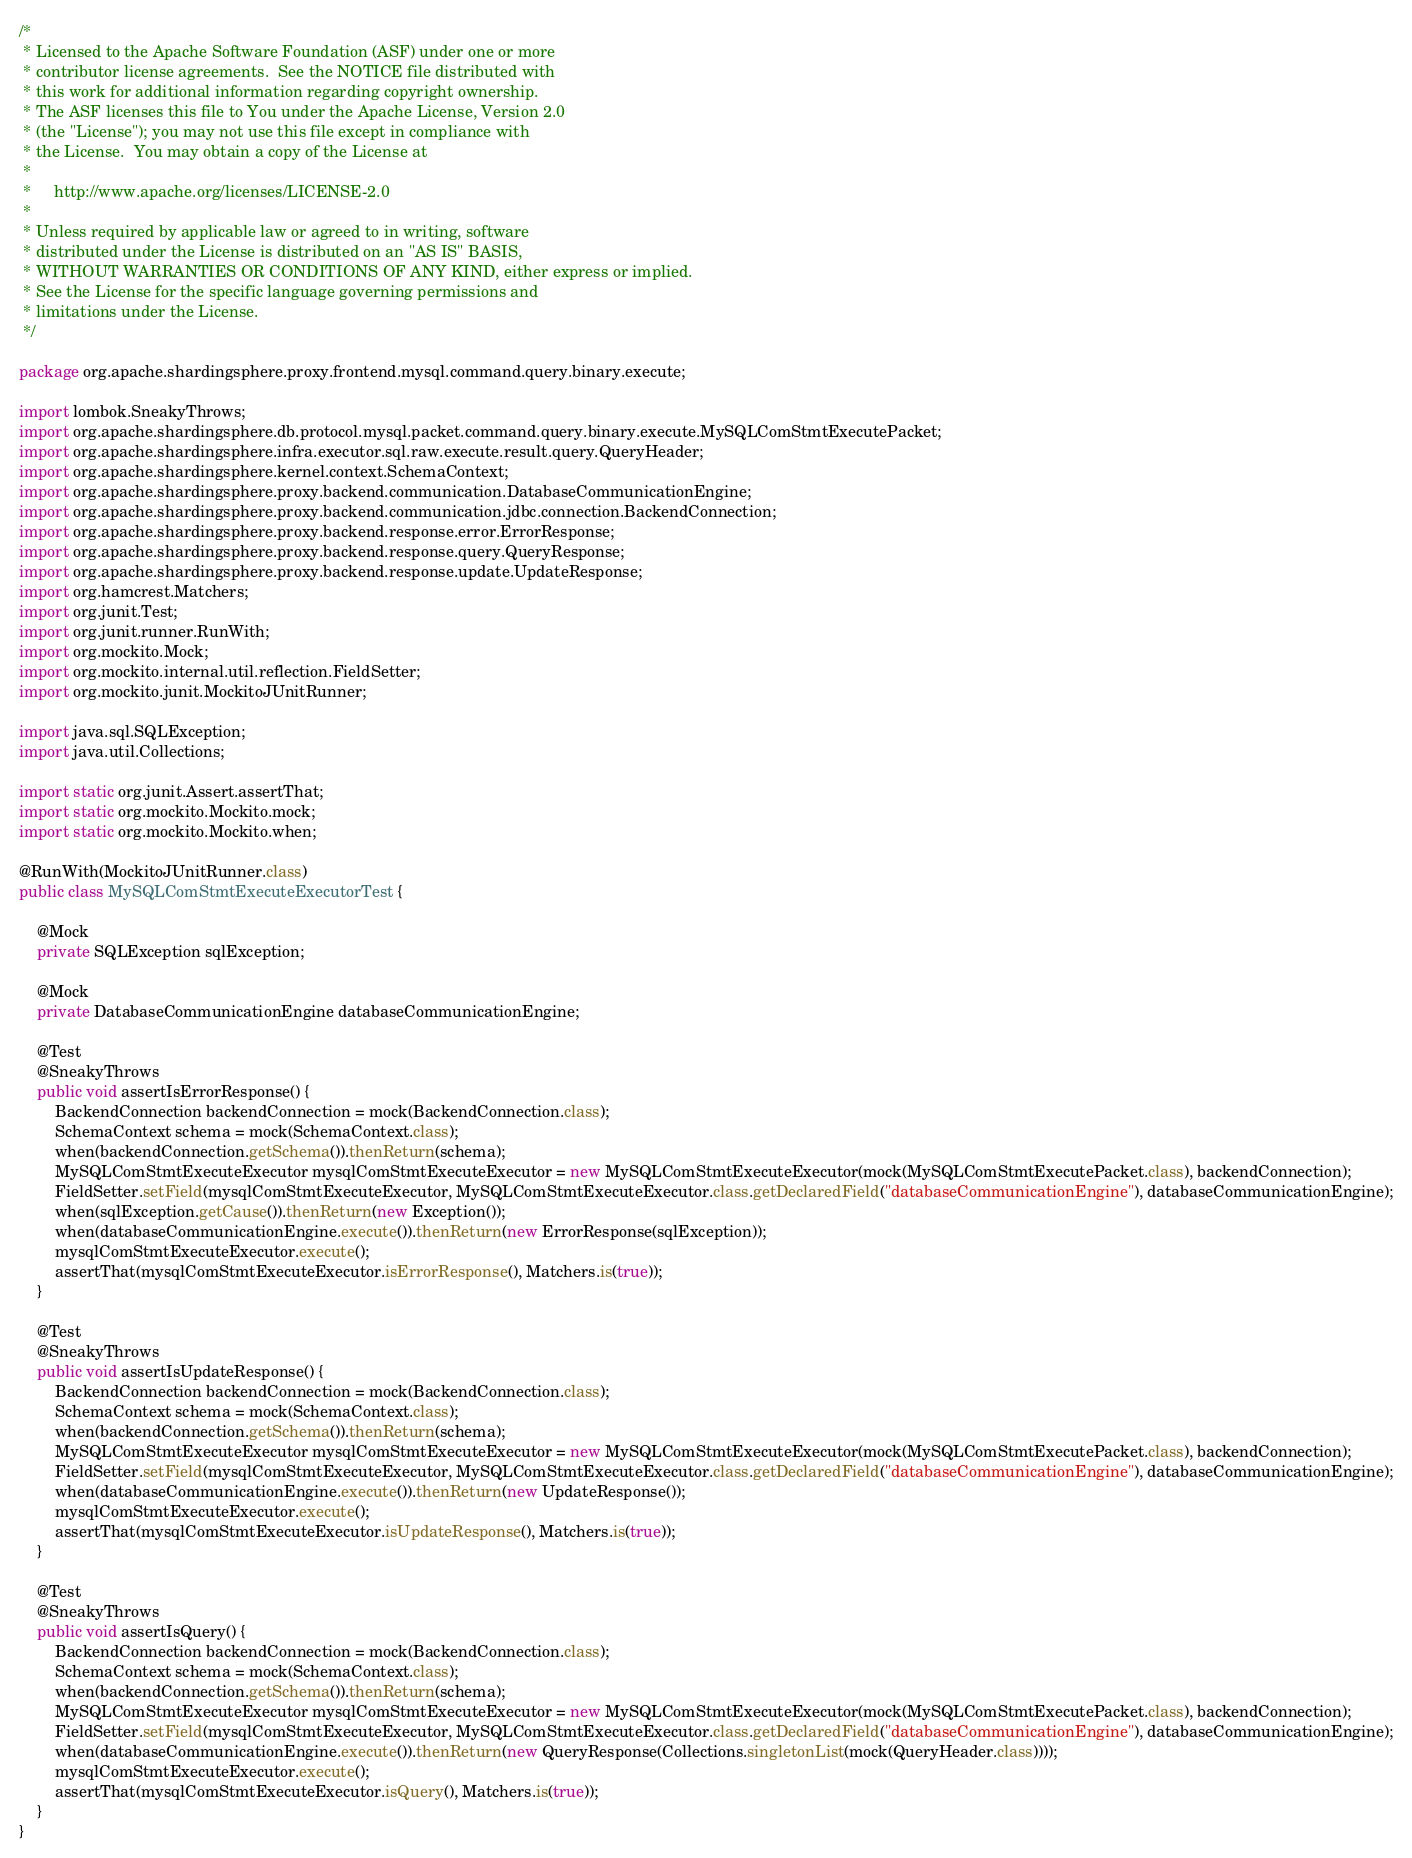<code> <loc_0><loc_0><loc_500><loc_500><_Java_>/*
 * Licensed to the Apache Software Foundation (ASF) under one or more
 * contributor license agreements.  See the NOTICE file distributed with
 * this work for additional information regarding copyright ownership.
 * The ASF licenses this file to You under the Apache License, Version 2.0
 * (the "License"); you may not use this file except in compliance with
 * the License.  You may obtain a copy of the License at
 *
 *     http://www.apache.org/licenses/LICENSE-2.0
 *
 * Unless required by applicable law or agreed to in writing, software
 * distributed under the License is distributed on an "AS IS" BASIS,
 * WITHOUT WARRANTIES OR CONDITIONS OF ANY KIND, either express or implied.
 * See the License for the specific language governing permissions and
 * limitations under the License.
 */

package org.apache.shardingsphere.proxy.frontend.mysql.command.query.binary.execute;

import lombok.SneakyThrows;
import org.apache.shardingsphere.db.protocol.mysql.packet.command.query.binary.execute.MySQLComStmtExecutePacket;
import org.apache.shardingsphere.infra.executor.sql.raw.execute.result.query.QueryHeader;
import org.apache.shardingsphere.kernel.context.SchemaContext;
import org.apache.shardingsphere.proxy.backend.communication.DatabaseCommunicationEngine;
import org.apache.shardingsphere.proxy.backend.communication.jdbc.connection.BackendConnection;
import org.apache.shardingsphere.proxy.backend.response.error.ErrorResponse;
import org.apache.shardingsphere.proxy.backend.response.query.QueryResponse;
import org.apache.shardingsphere.proxy.backend.response.update.UpdateResponse;
import org.hamcrest.Matchers;
import org.junit.Test;
import org.junit.runner.RunWith;
import org.mockito.Mock;
import org.mockito.internal.util.reflection.FieldSetter;
import org.mockito.junit.MockitoJUnitRunner;

import java.sql.SQLException;
import java.util.Collections;

import static org.junit.Assert.assertThat;
import static org.mockito.Mockito.mock;
import static org.mockito.Mockito.when;

@RunWith(MockitoJUnitRunner.class)
public class MySQLComStmtExecuteExecutorTest {
    
    @Mock
    private SQLException sqlException;
    
    @Mock
    private DatabaseCommunicationEngine databaseCommunicationEngine;
    
    @Test
    @SneakyThrows
    public void assertIsErrorResponse() {
        BackendConnection backendConnection = mock(BackendConnection.class);
        SchemaContext schema = mock(SchemaContext.class);
        when(backendConnection.getSchema()).thenReturn(schema);
        MySQLComStmtExecuteExecutor mysqlComStmtExecuteExecutor = new MySQLComStmtExecuteExecutor(mock(MySQLComStmtExecutePacket.class), backendConnection);
        FieldSetter.setField(mysqlComStmtExecuteExecutor, MySQLComStmtExecuteExecutor.class.getDeclaredField("databaseCommunicationEngine"), databaseCommunicationEngine);
        when(sqlException.getCause()).thenReturn(new Exception());
        when(databaseCommunicationEngine.execute()).thenReturn(new ErrorResponse(sqlException));
        mysqlComStmtExecuteExecutor.execute();
        assertThat(mysqlComStmtExecuteExecutor.isErrorResponse(), Matchers.is(true));
    }
    
    @Test
    @SneakyThrows
    public void assertIsUpdateResponse() {
        BackendConnection backendConnection = mock(BackendConnection.class);
        SchemaContext schema = mock(SchemaContext.class);
        when(backendConnection.getSchema()).thenReturn(schema);
        MySQLComStmtExecuteExecutor mysqlComStmtExecuteExecutor = new MySQLComStmtExecuteExecutor(mock(MySQLComStmtExecutePacket.class), backendConnection);
        FieldSetter.setField(mysqlComStmtExecuteExecutor, MySQLComStmtExecuteExecutor.class.getDeclaredField("databaseCommunicationEngine"), databaseCommunicationEngine);
        when(databaseCommunicationEngine.execute()).thenReturn(new UpdateResponse());
        mysqlComStmtExecuteExecutor.execute();
        assertThat(mysqlComStmtExecuteExecutor.isUpdateResponse(), Matchers.is(true));
    }
    
    @Test
    @SneakyThrows
    public void assertIsQuery() {
        BackendConnection backendConnection = mock(BackendConnection.class);
        SchemaContext schema = mock(SchemaContext.class);
        when(backendConnection.getSchema()).thenReturn(schema);
        MySQLComStmtExecuteExecutor mysqlComStmtExecuteExecutor = new MySQLComStmtExecuteExecutor(mock(MySQLComStmtExecutePacket.class), backendConnection);
        FieldSetter.setField(mysqlComStmtExecuteExecutor, MySQLComStmtExecuteExecutor.class.getDeclaredField("databaseCommunicationEngine"), databaseCommunicationEngine);
        when(databaseCommunicationEngine.execute()).thenReturn(new QueryResponse(Collections.singletonList(mock(QueryHeader.class))));
        mysqlComStmtExecuteExecutor.execute();
        assertThat(mysqlComStmtExecuteExecutor.isQuery(), Matchers.is(true));
    }
}
</code> 